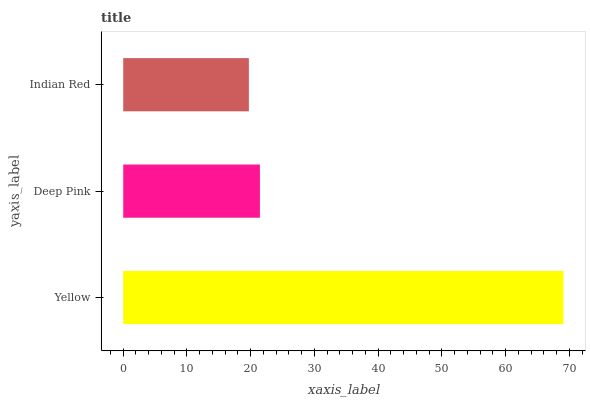Is Indian Red the minimum?
Answer yes or no. Yes. Is Yellow the maximum?
Answer yes or no. Yes. Is Deep Pink the minimum?
Answer yes or no. No. Is Deep Pink the maximum?
Answer yes or no. No. Is Yellow greater than Deep Pink?
Answer yes or no. Yes. Is Deep Pink less than Yellow?
Answer yes or no. Yes. Is Deep Pink greater than Yellow?
Answer yes or no. No. Is Yellow less than Deep Pink?
Answer yes or no. No. Is Deep Pink the high median?
Answer yes or no. Yes. Is Deep Pink the low median?
Answer yes or no. Yes. Is Indian Red the high median?
Answer yes or no. No. Is Yellow the low median?
Answer yes or no. No. 